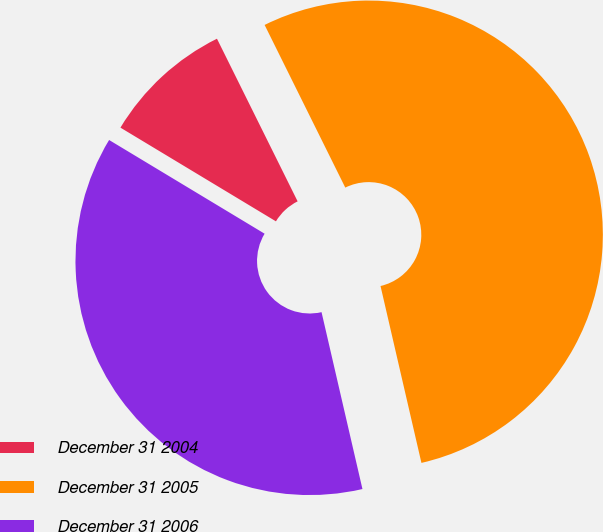<chart> <loc_0><loc_0><loc_500><loc_500><pie_chart><fcel>December 31 2004<fcel>December 31 2005<fcel>December 31 2006<nl><fcel>9.04%<fcel>53.71%<fcel>37.25%<nl></chart> 